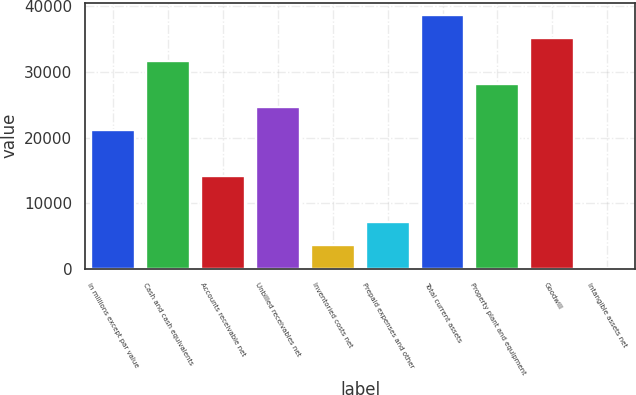Convert chart. <chart><loc_0><loc_0><loc_500><loc_500><bar_chart><fcel>in millions except par value<fcel>Cash and cash equivalents<fcel>Accounts receivable net<fcel>Unbilled receivables net<fcel>Inventoried costs net<fcel>Prepaid expenses and other<fcel>Total current assets<fcel>Property plant and equipment<fcel>Goodwill<fcel>Intangible assets net<nl><fcel>21097.6<fcel>31620.4<fcel>14082.4<fcel>24605.2<fcel>3559.6<fcel>7067.2<fcel>38635.6<fcel>28112.8<fcel>35128<fcel>52<nl></chart> 